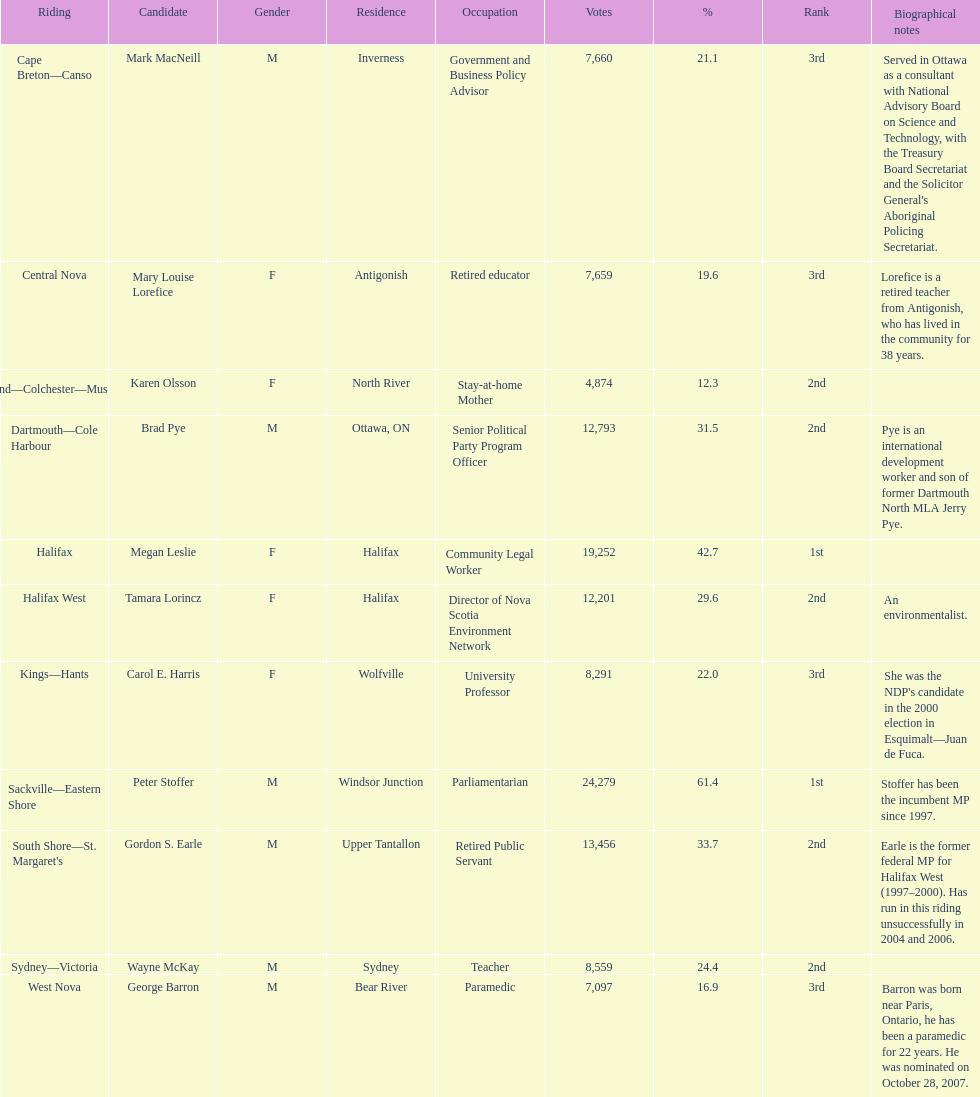Who garnered the minimum amount of votes? Karen Olsson. 